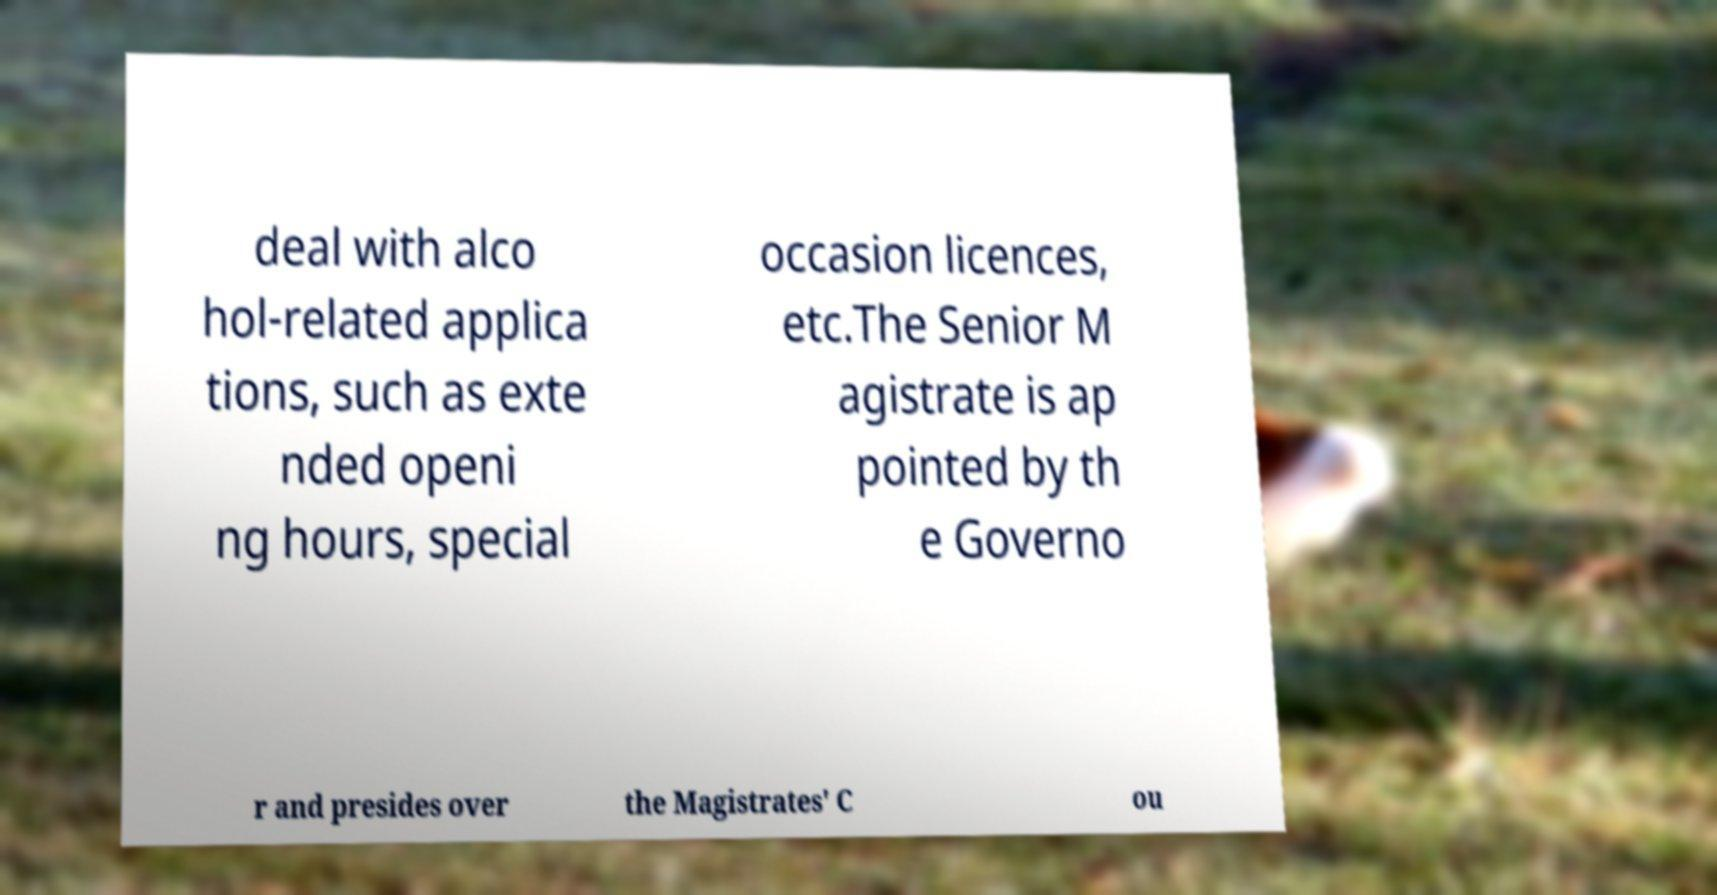What messages or text are displayed in this image? I need them in a readable, typed format. deal with alco hol-related applica tions, such as exte nded openi ng hours, special occasion licences, etc.The Senior M agistrate is ap pointed by th e Governo r and presides over the Magistrates' C ou 